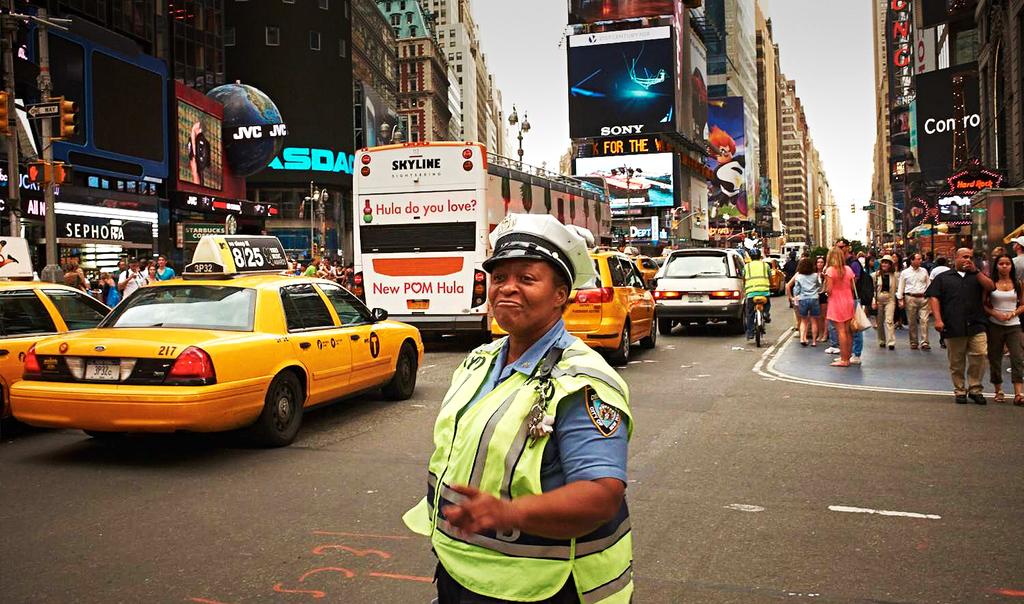Is the bus advertising new pom hula or old pom hula?
Your response must be concise. New pom hula. What are the three numbers on the back of the yellow car?
Provide a succinct answer. 217. 